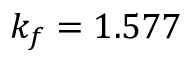<formula> <loc_0><loc_0><loc_500><loc_500>k _ { f } = 1 . 5 7 7</formula> 